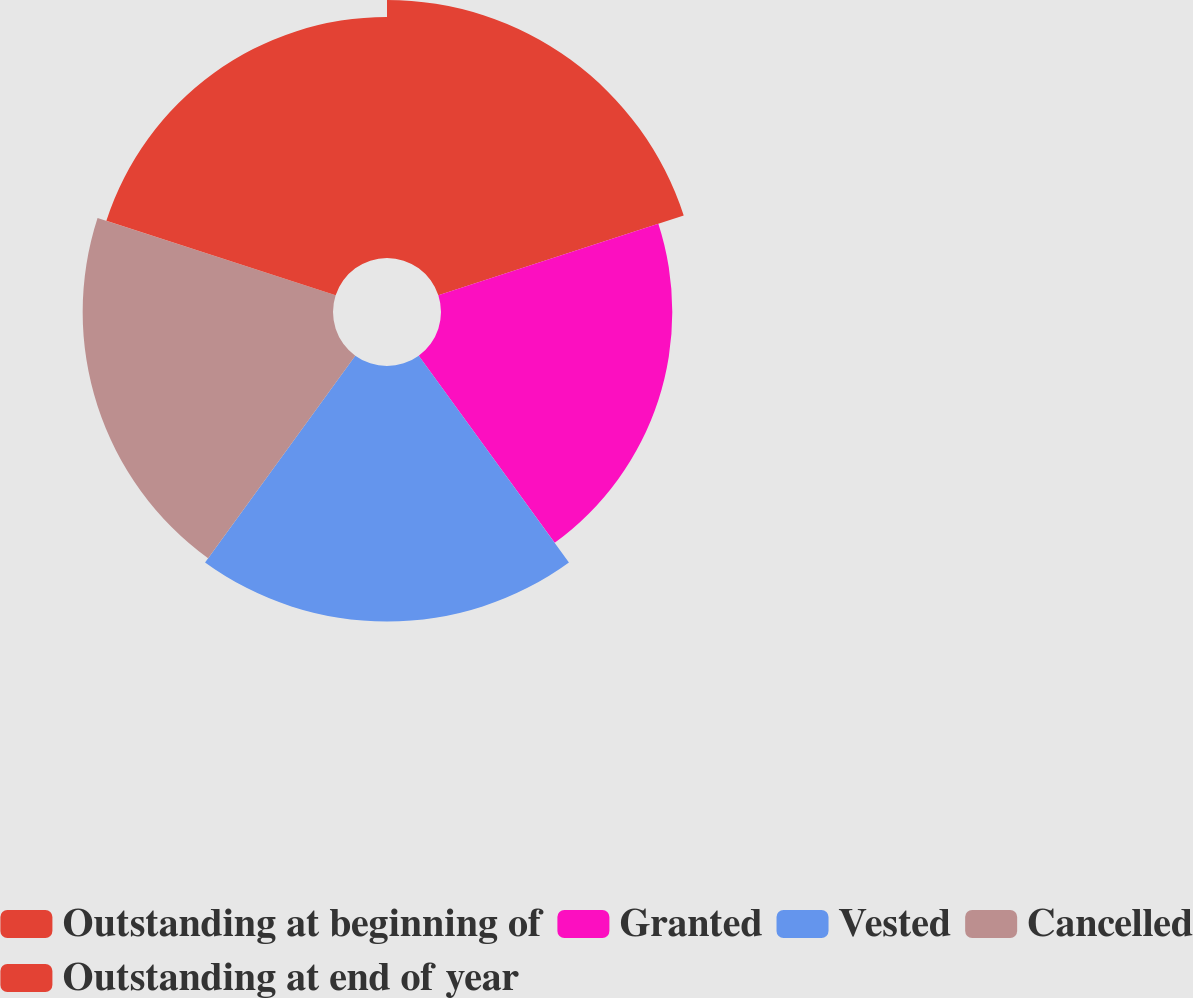Convert chart to OTSL. <chart><loc_0><loc_0><loc_500><loc_500><pie_chart><fcel>Outstanding at beginning of<fcel>Granted<fcel>Vested<fcel>Cancelled<fcel>Outstanding at end of year<nl><fcel>20.87%<fcel>18.71%<fcel>20.67%<fcel>20.25%<fcel>19.5%<nl></chart> 